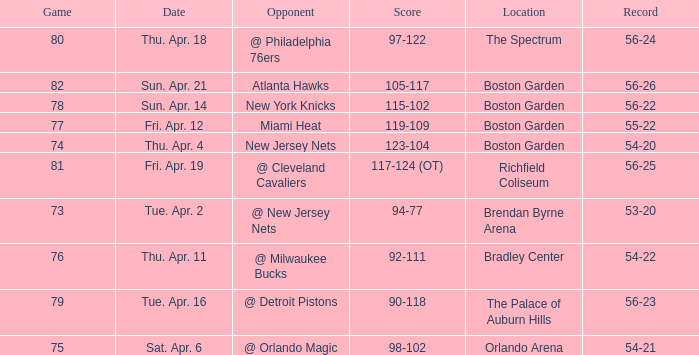Which Score has a Location of richfield coliseum? 117-124 (OT). 